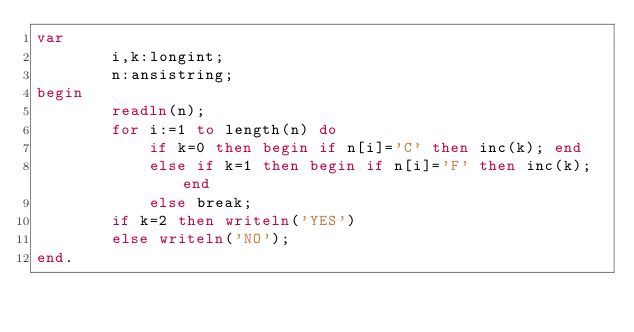Convert code to text. <code><loc_0><loc_0><loc_500><loc_500><_Pascal_>var
        i,k:longint;
        n:ansistring;
begin
        readln(n);
        for i:=1 to length(n) do
            if k=0 then begin if n[i]='C' then inc(k); end
            else if k=1 then begin if n[i]='F' then inc(k); end
            else break;
        if k=2 then writeln('YES')
        else writeln('NO');
end.</code> 